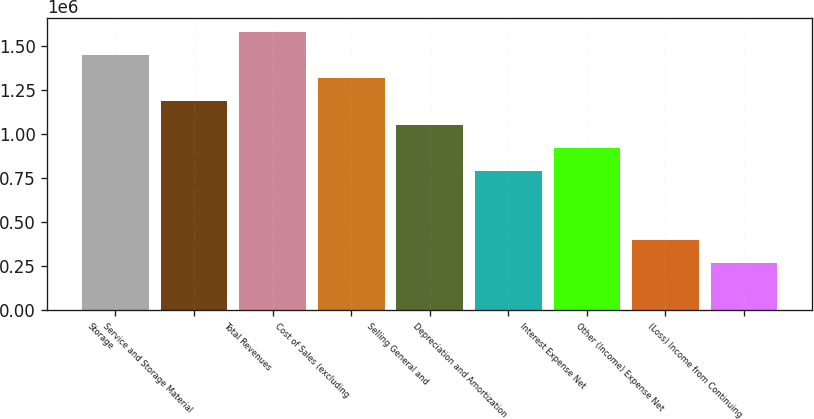Convert chart. <chart><loc_0><loc_0><loc_500><loc_500><bar_chart><fcel>Storage<fcel>Service and Storage Material<fcel>Total Revenues<fcel>Cost of Sales (excluding<fcel>Selling General and<fcel>Depreciation and Amortization<fcel>Interest Expense Net<fcel>Other (Income) Expense Net<fcel>(Loss) Income from Continuing<nl><fcel>1.45035e+06<fcel>1.18665e+06<fcel>1.5822e+06<fcel>1.3185e+06<fcel>1.0548e+06<fcel>791098<fcel>922948<fcel>395550<fcel>263700<nl></chart> 